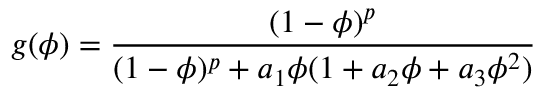<formula> <loc_0><loc_0><loc_500><loc_500>g ( \phi ) = \frac { ( 1 - \phi ) ^ { p } } { ( 1 - \phi ) ^ { p } + a _ { 1 } \phi ( 1 + a _ { 2 } \phi + a _ { 3 } \phi ^ { 2 } ) }</formula> 